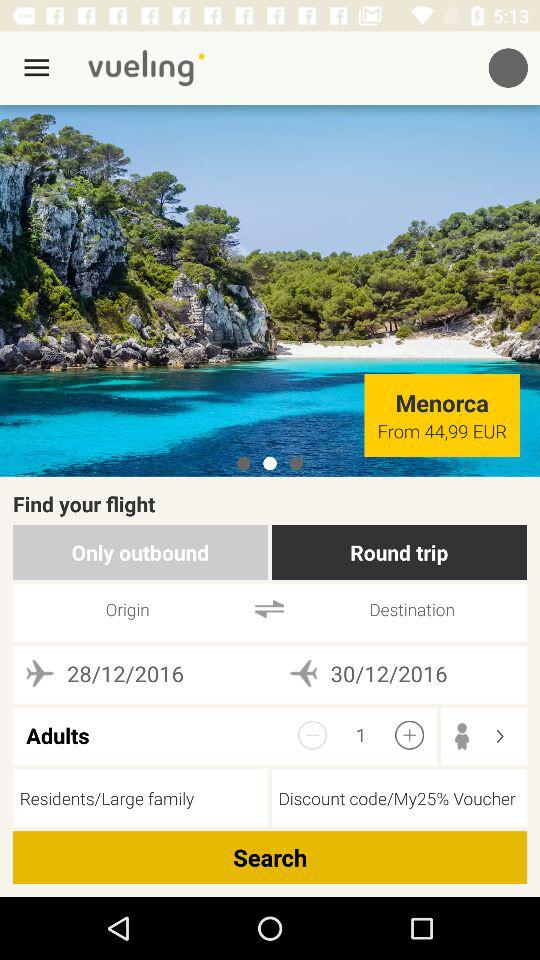How many people are traveling?
Answer the question using a single word or phrase. 1 